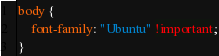<code> <loc_0><loc_0><loc_500><loc_500><_CSS_>body {
    font-family: "Ubuntu" !important;
}
</code> 